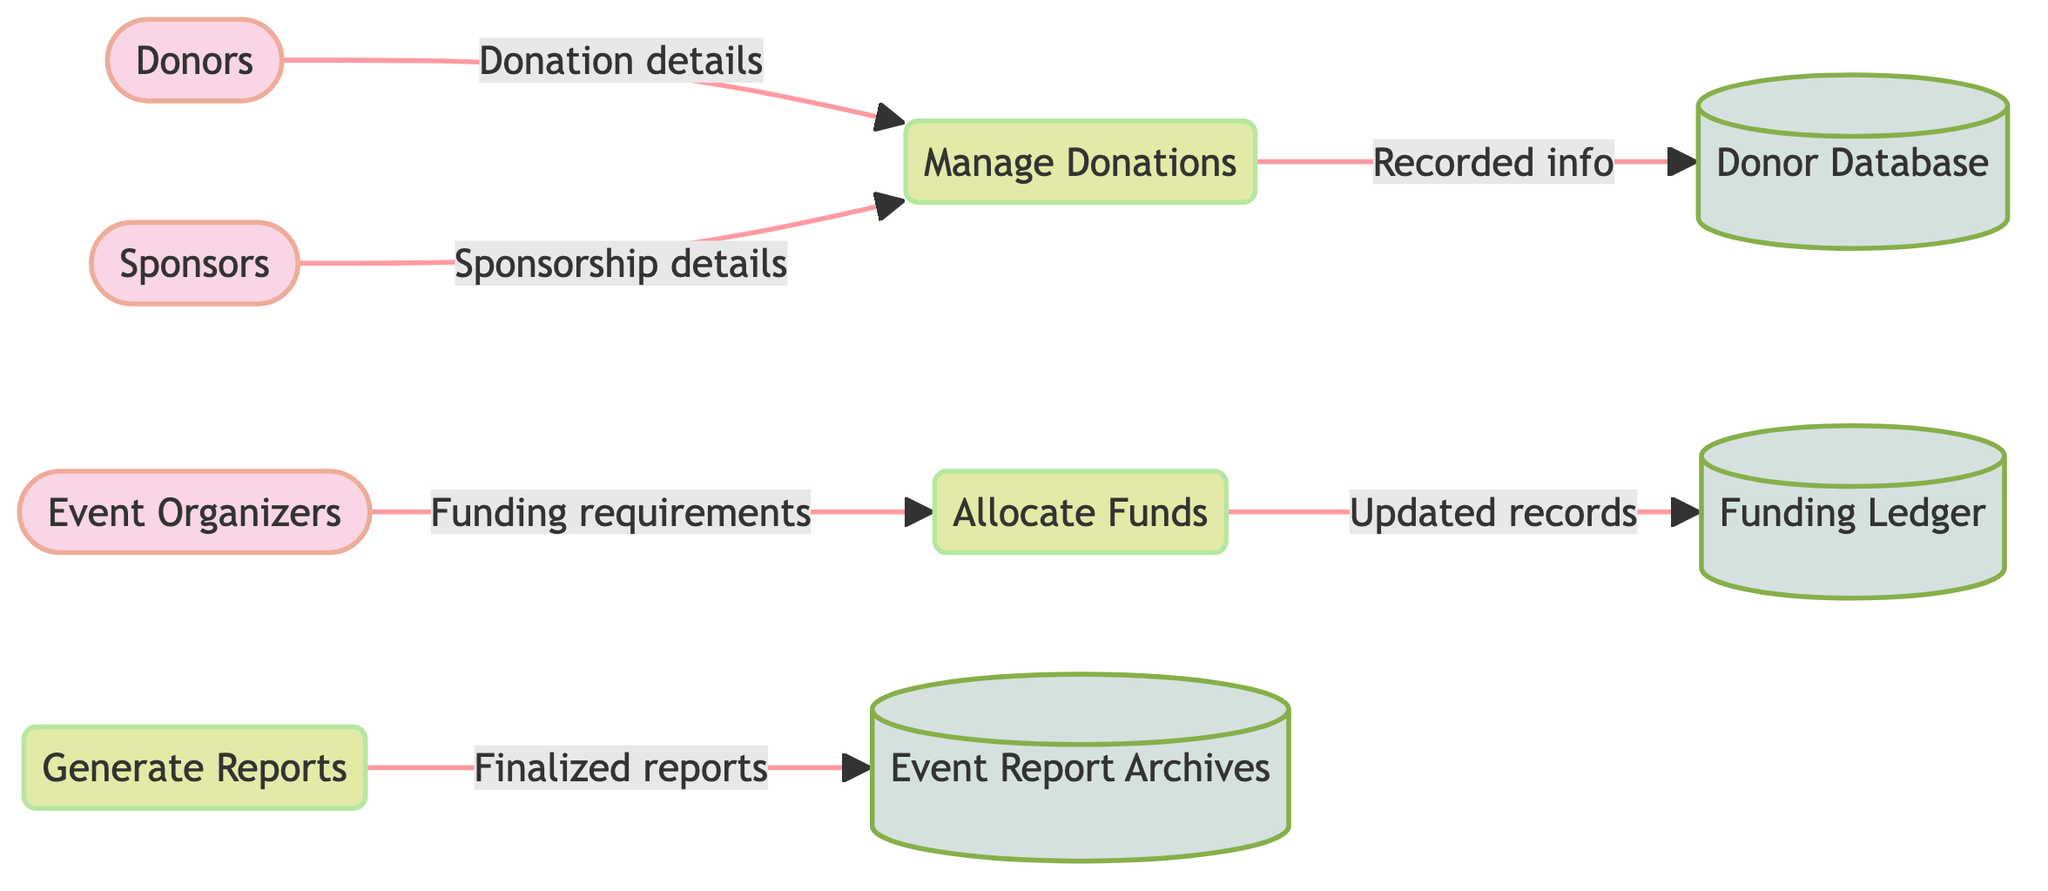What are the three external entities involved? The diagram lists three external entities: Donors, Event Organizers, and Sponsors. These are identified at the top of the diagram as contributors to the donation and funding management process for the event.
Answer: Donors, Event Organizers, Sponsors How many processes are represented in the diagram? There are three distinct processes labeled in the diagram: Manage Donations, Allocate Funds, and Generate Reports. By counting each process box, we can confirm the total.
Answer: Three What does the Manage Donations process receive from Donors? The flow from Donors to Manage Donations indicates that this process receives "Donation details submitted by donors." This description clarifies the nature of the input.
Answer: Donation details Where does the Allocate Funds process send updated records? The Allocate Funds process flows into the Funding Ledger, which indicates that it stores updated records of fund allocations, providing a clear link between these two elements.
Answer: Funding Ledger Which data store archives the final reports generated? The Generate Reports process flows into Event Report Archives, indicating this datastore is responsible for storing the finalized reports for future reference.
Answer: Event Report Archives What type of information is stored in the Donor Database? The Donor Database stores information related to donors, including contact details, donation amounts, and donation history, as outlined in the description associated with this datastore.
Answer: Donor information What do Event Organizers provide to the Allocate Funds process? The Event Organizers send "Funding requirements for different aspects of the event" to the Allocate Funds process, indicating the necessary financial needs for the event’s components.
Answer: Funding requirements How many data stores are illustrated in the diagram? The diagram depicts three data stores: Donor Database, Funding Ledger, and Event Report Archives. By counting each data store, we establish the total count.
Answer: Three What is the purpose of the Generate Reports process? The Generate Reports process is designed to create financial and progress reports, which are crucial for transparency and decision-making concerning the event's funding and outcomes.
Answer: Creating reports 